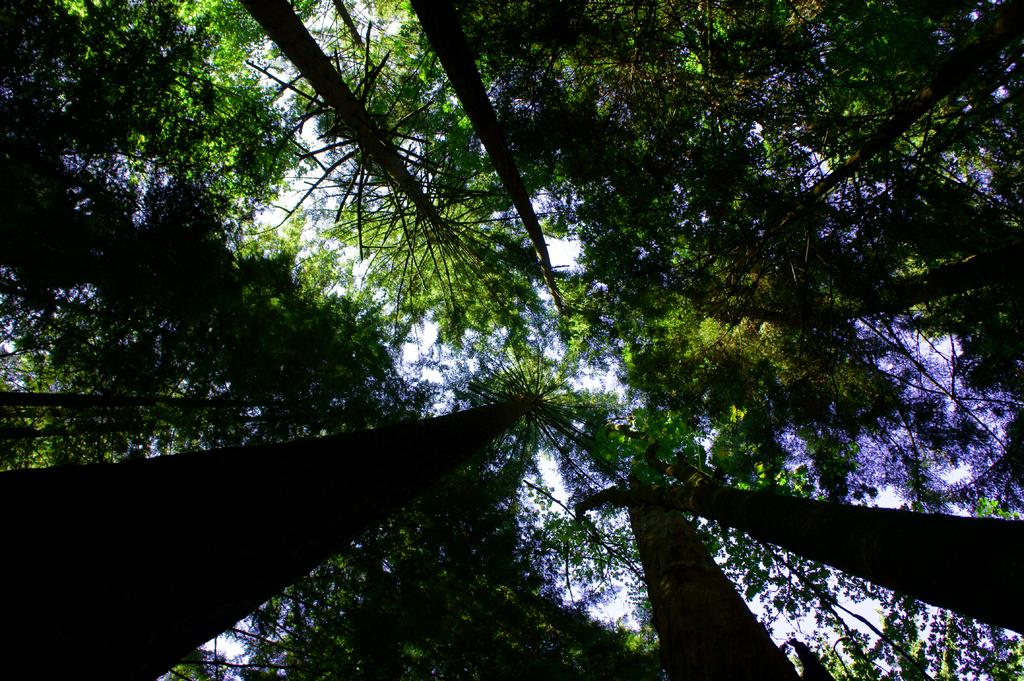What is the primary feature of the image? The primary feature of the image is the presence of many trees. Can you describe the sky in the image? Some part of the sky is visible in the image. What type of eggnog can be seen in the image? There is no eggnog present in the image; it features many trees and a part of the sky. Can you describe the kettle in the image? There is no kettle present in the image. 